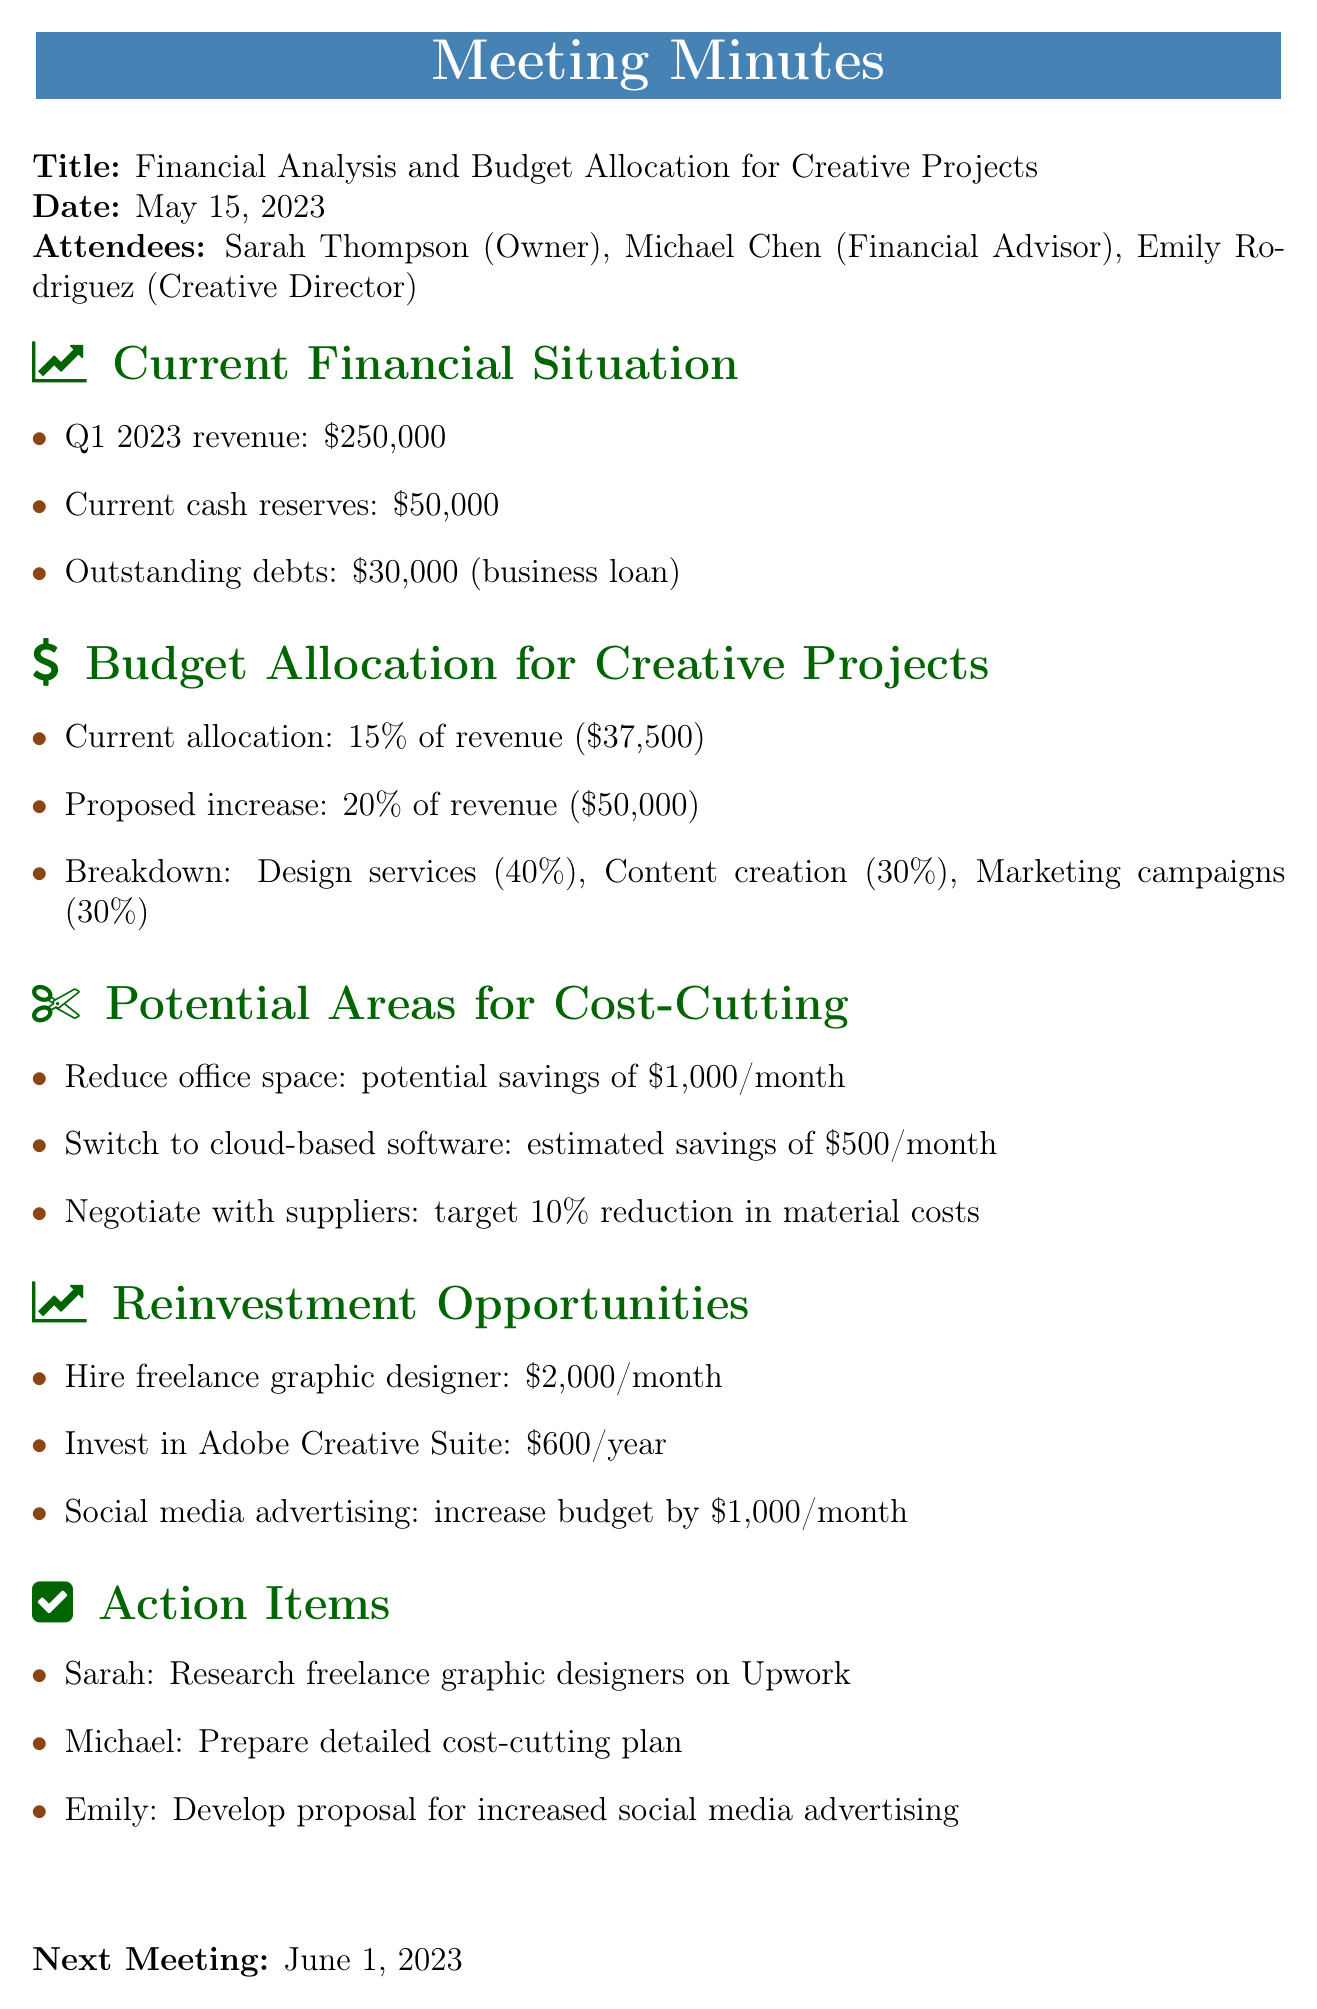What was the Q1 2023 revenue? The revenue for Q1 2023 is explicitly stated in the document as $250,000.
Answer: $250,000 How much is the current cash reserve? The document provides the amount of current cash reserves, which is $50,000.
Answer: $50,000 What percentage of revenue is currently allocated for creative projects? The document clearly states that the current allocation is 15% of revenue.
Answer: 15% What are the proposed savings from reducing office space? The potential savings from reducing office space are outlined in the document as $1,000 per month.
Answer: $1,000/month How much is the proposed budget for social media advertising increase? The proposed increase for social media advertising is detailed in the document as an additional $1,000 per month.
Answer: $1,000/month What is the target reduction in material costs when negotiating with suppliers? The document specifies a target reduction of 10% in material costs for negotiations with suppliers.
Answer: 10% Who is responsible for researching freelance graphic designers? The action item indicates that Sarah is responsible for researching freelance graphic designers on Upwork.
Answer: Sarah When is the next meeting scheduled? The document notes that the next meeting is scheduled for June 1, 2023.
Answer: June 1, 2023 What specific software investment is mentioned? The investment mentioned for software is the Adobe Creative Suite, which costs $600 per year.
Answer: Adobe Creative Suite 